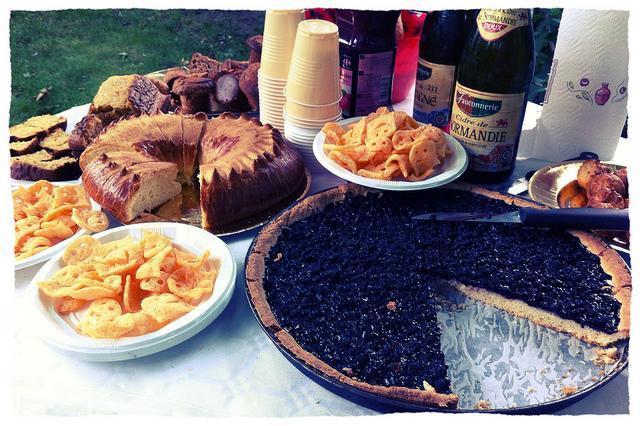How many bottles are in the picture?
Give a very brief answer. 4. How many bowls can you see?
Give a very brief answer. 3. How many cups are there?
Give a very brief answer. 2. How many cakes can you see?
Give a very brief answer. 2. 